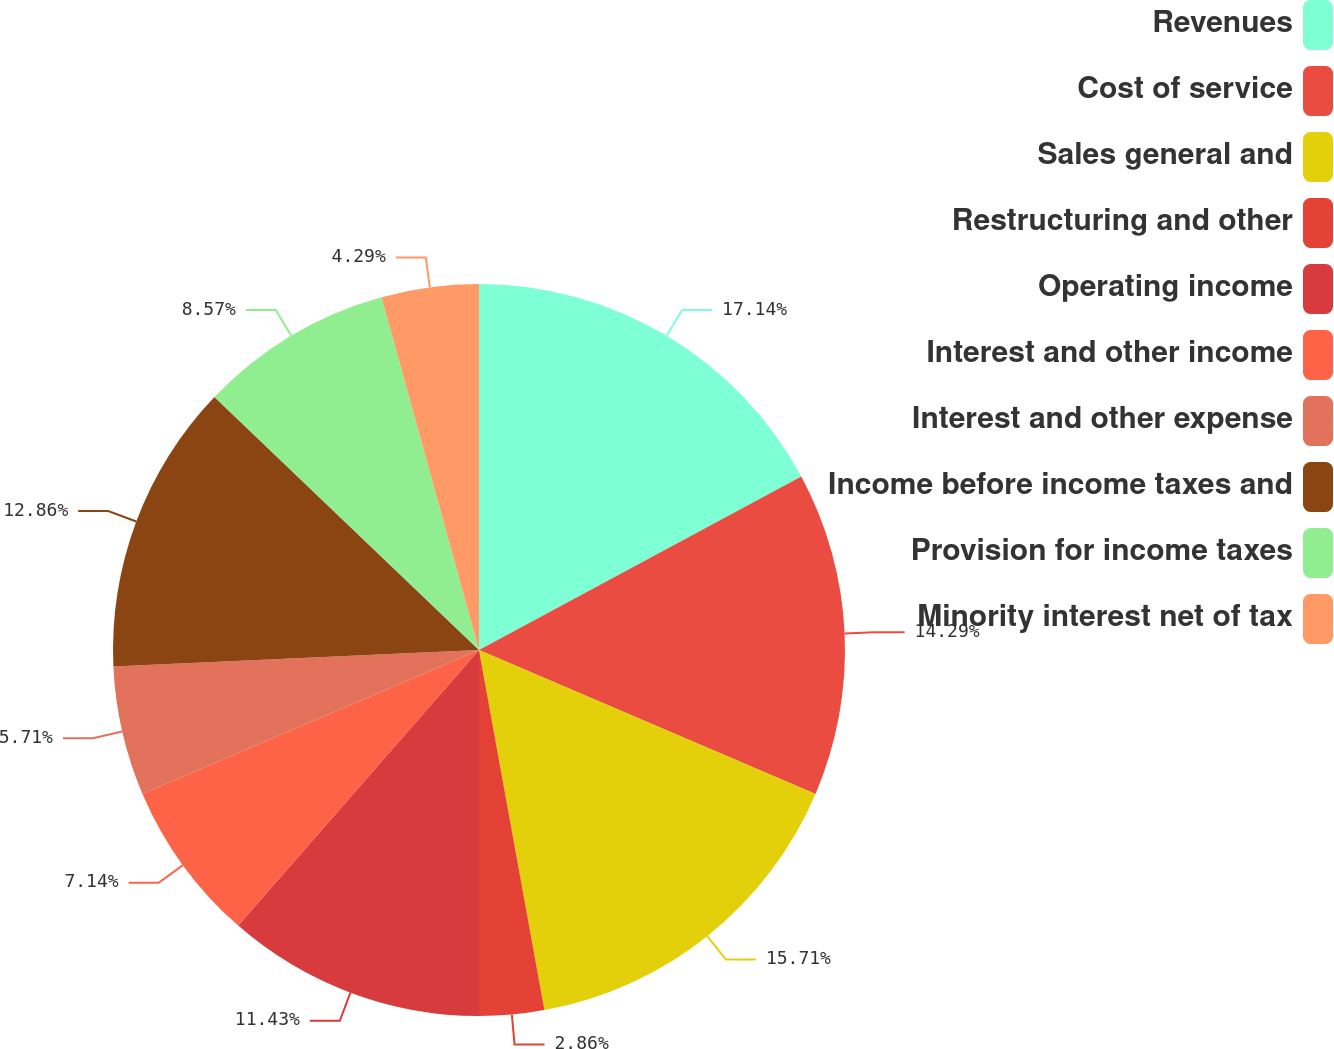<chart> <loc_0><loc_0><loc_500><loc_500><pie_chart><fcel>Revenues<fcel>Cost of service<fcel>Sales general and<fcel>Restructuring and other<fcel>Operating income<fcel>Interest and other income<fcel>Interest and other expense<fcel>Income before income taxes and<fcel>Provision for income taxes<fcel>Minority interest net of tax<nl><fcel>17.14%<fcel>14.29%<fcel>15.71%<fcel>2.86%<fcel>11.43%<fcel>7.14%<fcel>5.71%<fcel>12.86%<fcel>8.57%<fcel>4.29%<nl></chart> 